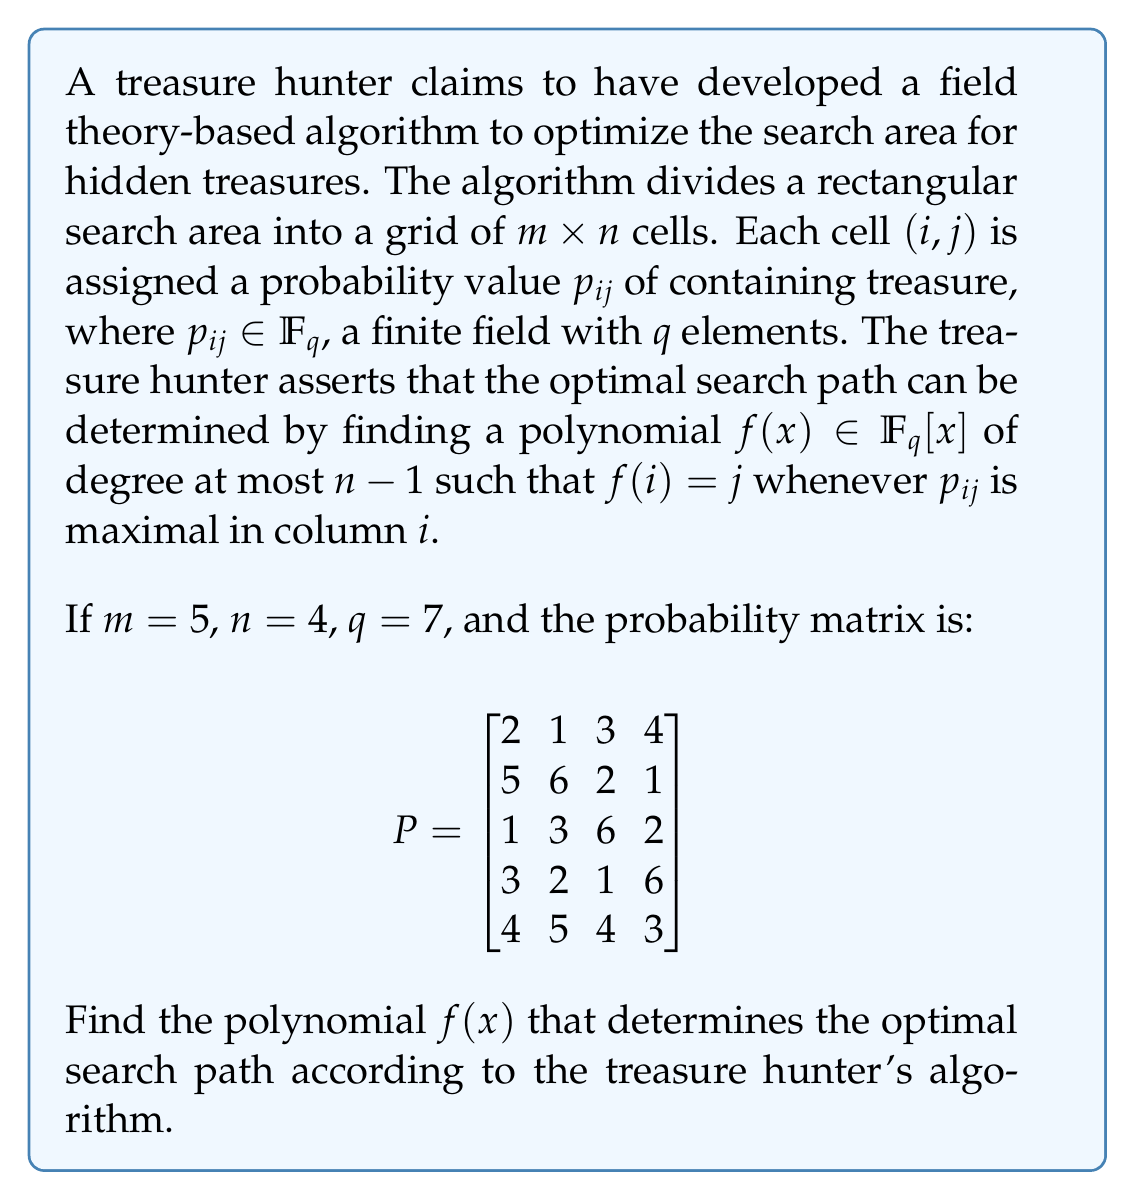Provide a solution to this math problem. To solve this problem, we need to follow these steps:

1. Identify the maximum probability in each column of the matrix $P$.
2. Determine the corresponding row indices for these maximum probabilities.
3. Use these points to construct a polynomial $f(x)$ of degree at most 3 (since $n-1 = 3$) in $\mathbb{F}_7[x]$ that passes through these points.

Step 1 & 2: Finding the maximum probabilities and their row indices:
- Column 1: Max = 5, Row index = 2
- Column 2: Max = 6, Row index = 2
- Column 3: Max = 6, Row index = 3
- Column 4: Max = 6, Row index = 4

Step 3: Constructing the polynomial using Lagrange interpolation:

We need to find $f(x)$ such that:
$f(1) = 2$, $f(2) = 2$, $f(3) = 3$, $f(4) = 4$

The Lagrange interpolation formula is:

$f(x) = \sum_{i=1}^{4} y_i \prod_{j \neq i} \frac{x - x_j}{x_i - x_j}$

Calculating each term (remember all calculations are in $\mathbb{F}_7$):

$L_1(x) = 2 \cdot \frac{(x-2)(x-3)(x-4)}{(1-2)(1-3)(1-4)} = 2 \cdot \frac{(x-2)(x-3)(x-4)}{6} = 5(x-2)(x-3)(x-4)$

$L_2(x) = 2 \cdot \frac{(x-1)(x-3)(x-4)}{(2-1)(2-3)(2-4)} = 2 \cdot \frac{(x-1)(x-3)(x-4)}{2} = (x-1)(x-3)(x-4)$

$L_3(x) = 3 \cdot \frac{(x-1)(x-2)(x-4)}{(3-1)(3-2)(3-4)} = 3 \cdot \frac{(x-1)(x-2)(x-4)}{2} = 5(x-1)(x-2)(x-4)$

$L_4(x) = 4 \cdot \frac{(x-1)(x-2)(x-3)}{(4-1)(4-2)(4-3)} = 4 \cdot \frac{(x-1)(x-2)(x-3)}{6} = 4(x-1)(x-2)(x-3)$

$f(x) = L_1(x) + L_2(x) + L_3(x) + L_4(x)$

Expanding and simplifying in $\mathbb{F}_7$:

$f(x) = 5x^3 + 6x^2 + 3x + 2$

This polynomial satisfies all the required conditions and is of degree 3.
Answer: $f(x) = 5x^3 + 6x^2 + 3x + 2$ in $\mathbb{F}_7[x]$ 